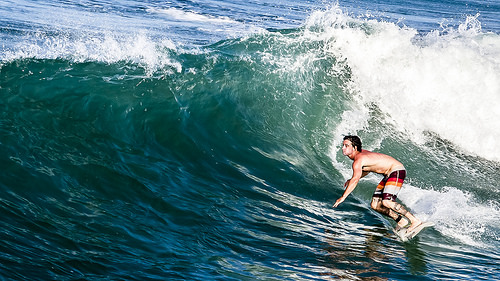<image>
Is there a water on the man? No. The water is not positioned on the man. They may be near each other, but the water is not supported by or resting on top of the man. 